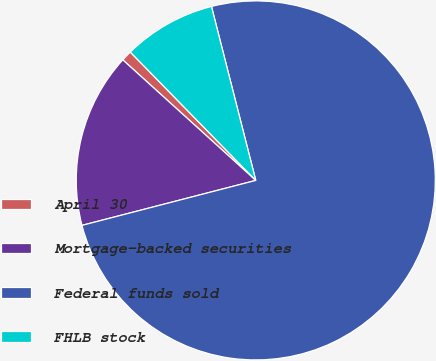Convert chart. <chart><loc_0><loc_0><loc_500><loc_500><pie_chart><fcel>April 30<fcel>Mortgage-backed securities<fcel>Federal funds sold<fcel>FHLB stock<nl><fcel>0.96%<fcel>15.75%<fcel>74.94%<fcel>8.35%<nl></chart> 